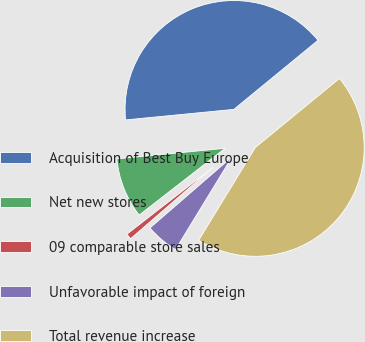<chart> <loc_0><loc_0><loc_500><loc_500><pie_chart><fcel>Acquisition of Best Buy Europe<fcel>Net new stores<fcel>09 comparable store sales<fcel>Unfavorable impact of foreign<fcel>Total revenue increase<nl><fcel>40.61%<fcel>8.97%<fcel>0.85%<fcel>4.91%<fcel>44.67%<nl></chart> 